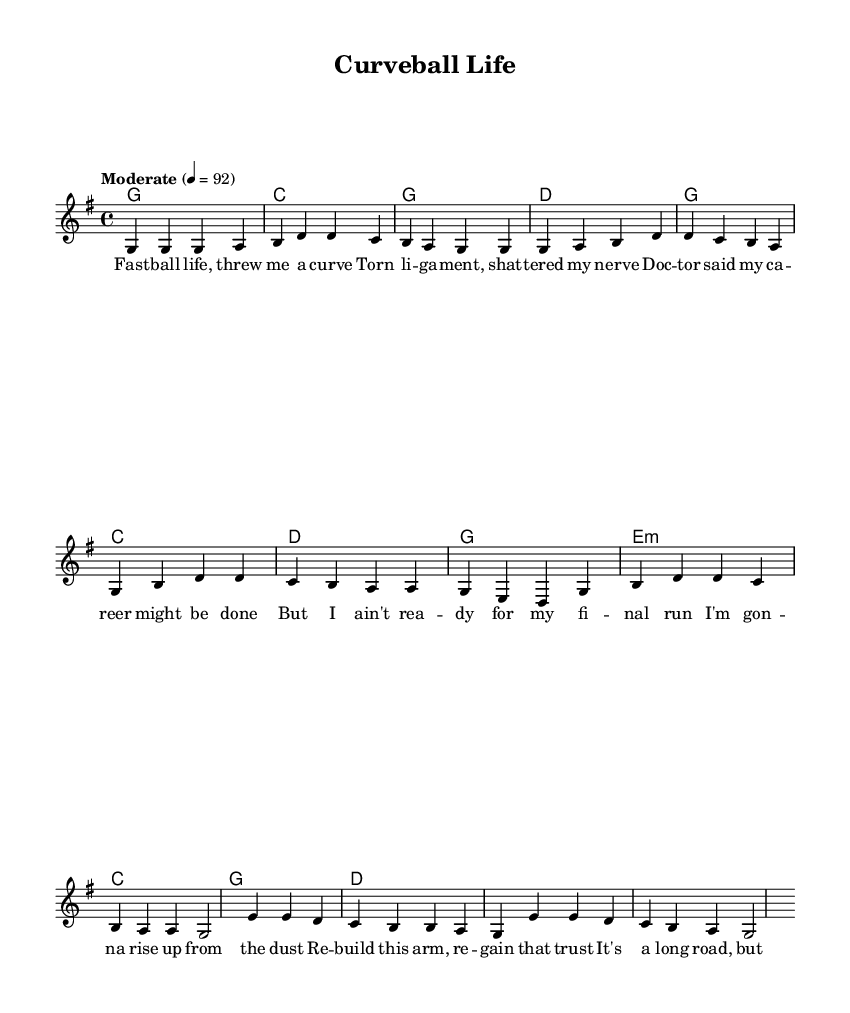What is the key signature of this music? The key signature is G major, which has one sharp (F#). This can be identified by looking at the key signature indicated at the beginning of the staff.
Answer: G major What is the time signature of this music? The time signature is 4/4, which indicates that there are four beats in each measure and a quarter note receives one beat. This is typically noted at the beginning of the piece, right after the key signature.
Answer: 4/4 What is the tempo marking for this piece? The tempo marking is "Moderate" with a metronome marking of 92 beats per minute. This gives an indication of the speed at which the piece should be played, found at the top part of the music sheet.
Answer: Moderate How many verses are in the song? There is one verse in the song, which is evident from the structure of the lyrics provided, as only one set of verse lyrics is included before the chorus.
Answer: One What is the harmonic progression used in the chorus? The harmonic progression in the chorus follows G, C, D, G. This can be determined by looking at the chord symbols written above the lyrics during the chorus section.
Answer: G, C, D, G What theme does the song convey? The song conveys the theme of overcoming adversity, as reflected in the lyrics discussing resilience and recovery from injury. This can be inferred from both the lyrics and the general tone of the music.
Answer: Overcoming adversity What type of song structure is used in this piece? The song structure follows a Verse-Chorus-Bridge format, which is common in country music, as illustrated by the labeled sections in the lyrics and the distinct transitions between these sections.
Answer: Verse-Chorus-Bridge 